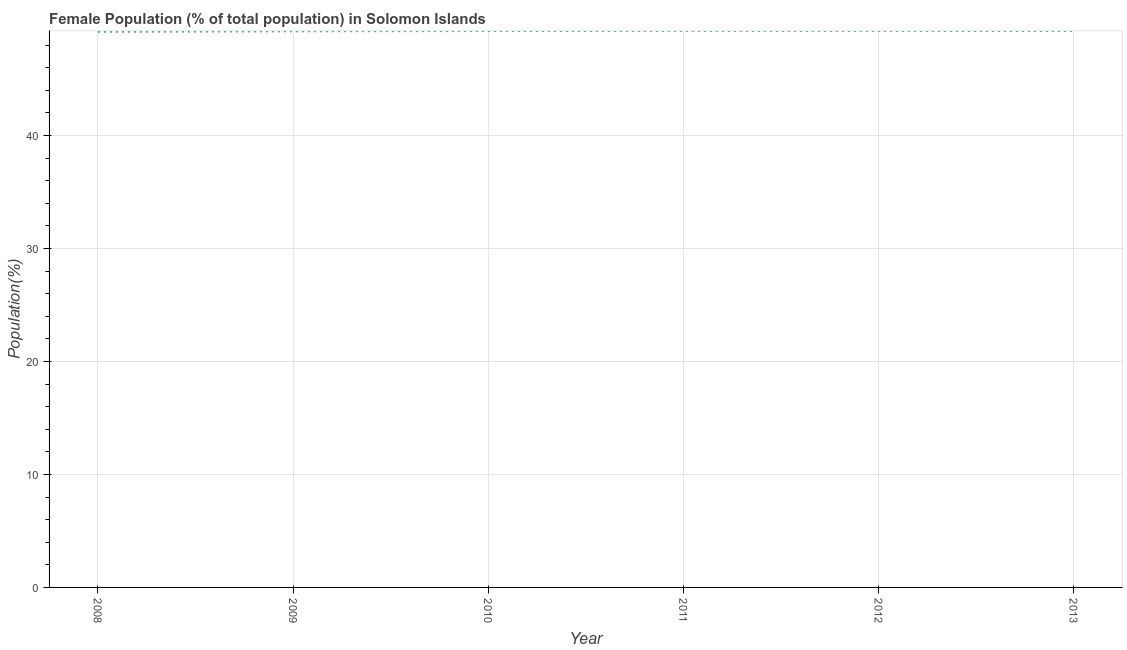What is the female population in 2010?
Keep it short and to the point. 49.25. Across all years, what is the maximum female population?
Provide a short and direct response. 49.26. Across all years, what is the minimum female population?
Ensure brevity in your answer.  49.17. What is the sum of the female population?
Make the answer very short. 295.39. What is the difference between the female population in 2008 and 2011?
Offer a very short reply. -0.09. What is the average female population per year?
Provide a succinct answer. 49.23. What is the median female population?
Your response must be concise. 49.25. What is the ratio of the female population in 2008 to that in 2009?
Make the answer very short. 1. Is the difference between the female population in 2012 and 2013 greater than the difference between any two years?
Provide a short and direct response. No. What is the difference between the highest and the second highest female population?
Your response must be concise. 0. What is the difference between the highest and the lowest female population?
Give a very brief answer. 0.09. In how many years, is the female population greater than the average female population taken over all years?
Give a very brief answer. 4. Does the female population monotonically increase over the years?
Your answer should be very brief. No. How many years are there in the graph?
Your answer should be compact. 6. What is the difference between two consecutive major ticks on the Y-axis?
Your answer should be very brief. 10. Are the values on the major ticks of Y-axis written in scientific E-notation?
Your answer should be compact. No. What is the title of the graph?
Provide a succinct answer. Female Population (% of total population) in Solomon Islands. What is the label or title of the X-axis?
Your answer should be compact. Year. What is the label or title of the Y-axis?
Give a very brief answer. Population(%). What is the Population(%) of 2008?
Give a very brief answer. 49.17. What is the Population(%) of 2009?
Provide a succinct answer. 49.22. What is the Population(%) of 2010?
Your response must be concise. 49.25. What is the Population(%) of 2011?
Your answer should be compact. 49.26. What is the Population(%) of 2012?
Offer a very short reply. 49.26. What is the Population(%) in 2013?
Provide a short and direct response. 49.25. What is the difference between the Population(%) in 2008 and 2009?
Keep it short and to the point. -0.05. What is the difference between the Population(%) in 2008 and 2010?
Keep it short and to the point. -0.08. What is the difference between the Population(%) in 2008 and 2011?
Provide a succinct answer. -0.09. What is the difference between the Population(%) in 2008 and 2012?
Make the answer very short. -0.09. What is the difference between the Population(%) in 2008 and 2013?
Provide a short and direct response. -0.08. What is the difference between the Population(%) in 2009 and 2010?
Give a very brief answer. -0.03. What is the difference between the Population(%) in 2009 and 2011?
Provide a short and direct response. -0.04. What is the difference between the Population(%) in 2009 and 2012?
Provide a short and direct response. -0.04. What is the difference between the Population(%) in 2009 and 2013?
Keep it short and to the point. -0.03. What is the difference between the Population(%) in 2010 and 2011?
Keep it short and to the point. -0.01. What is the difference between the Population(%) in 2010 and 2012?
Your response must be concise. -0.01. What is the difference between the Population(%) in 2010 and 2013?
Offer a very short reply. -0. What is the difference between the Population(%) in 2011 and 2012?
Your answer should be compact. 0. What is the difference between the Population(%) in 2011 and 2013?
Make the answer very short. 0.01. What is the difference between the Population(%) in 2012 and 2013?
Give a very brief answer. 0.01. What is the ratio of the Population(%) in 2008 to that in 2009?
Your answer should be compact. 1. What is the ratio of the Population(%) in 2009 to that in 2010?
Make the answer very short. 1. What is the ratio of the Population(%) in 2010 to that in 2013?
Your answer should be compact. 1. What is the ratio of the Population(%) in 2011 to that in 2012?
Your response must be concise. 1. What is the ratio of the Population(%) in 2011 to that in 2013?
Provide a short and direct response. 1. What is the ratio of the Population(%) in 2012 to that in 2013?
Keep it short and to the point. 1. 